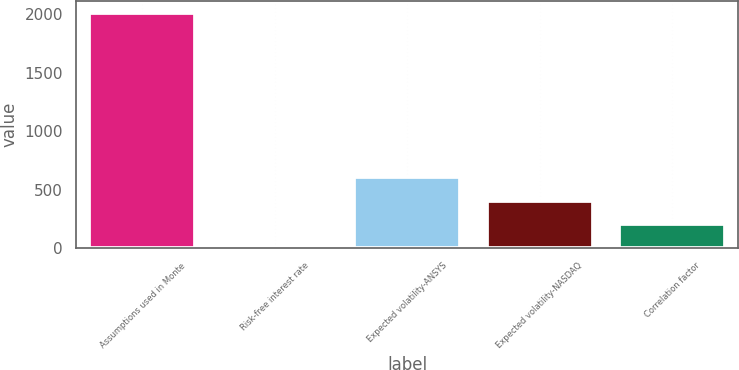<chart> <loc_0><loc_0><loc_500><loc_500><bar_chart><fcel>Assumptions used in Monte<fcel>Risk-free interest rate<fcel>Expected volatility-ANSYS<fcel>Expected volatility-NASDAQ<fcel>Correlation factor<nl><fcel>2012<fcel>0.16<fcel>603.7<fcel>402.52<fcel>201.34<nl></chart> 